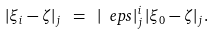<formula> <loc_0><loc_0><loc_500><loc_500>| \xi _ { i } - \zeta | _ { j } \ = \ | \ e p s | _ { j } ^ { i } \, | \xi _ { 0 } - \zeta | _ { j } .</formula> 